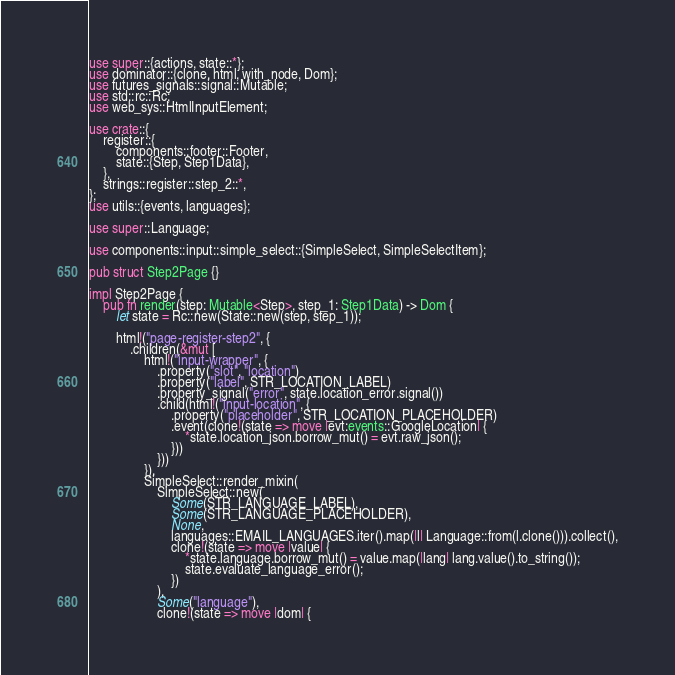Convert code to text. <code><loc_0><loc_0><loc_500><loc_500><_Rust_>use super::{actions, state::*};
use dominator::{clone, html, with_node, Dom};
use futures_signals::signal::Mutable;
use std::rc::Rc;
use web_sys::HtmlInputElement;

use crate::{
    register::{
        components::footer::Footer,
        state::{Step, Step1Data},
    },
    strings::register::step_2::*,
};
use utils::{events, languages};

use super::Language;

use components::input::simple_select::{SimpleSelect, SimpleSelectItem};

pub struct Step2Page {}

impl Step2Page {
    pub fn render(step: Mutable<Step>, step_1: Step1Data) -> Dom {
        let state = Rc::new(State::new(step, step_1));

        html!("page-register-step2", {
            .children(&mut [
                html!("input-wrapper", {
                    .property("slot", "location")
                    .property("label", STR_LOCATION_LABEL)
                    .property_signal("error", state.location_error.signal())
                    .child(html!("input-location", {
                        .property("placeholder", STR_LOCATION_PLACEHOLDER)
                        .event(clone!(state => move |evt:events::GoogleLocation| {
                            *state.location_json.borrow_mut() = evt.raw_json();
                        }))
                    }))
                }),
                SimpleSelect::render_mixin(
                    SimpleSelect::new(
                        Some(STR_LANGUAGE_LABEL),
                        Some(STR_LANGUAGE_PLACEHOLDER),
                        None,
                        languages::EMAIL_LANGUAGES.iter().map(|l| Language::from(l.clone())).collect(),
                        clone!(state => move |value| {
                            *state.language.borrow_mut() = value.map(|lang| lang.value().to_string());
                            state.evaluate_language_error();
                        })
                    ),
                    Some("language"),
                    clone!(state => move |dom| {</code> 